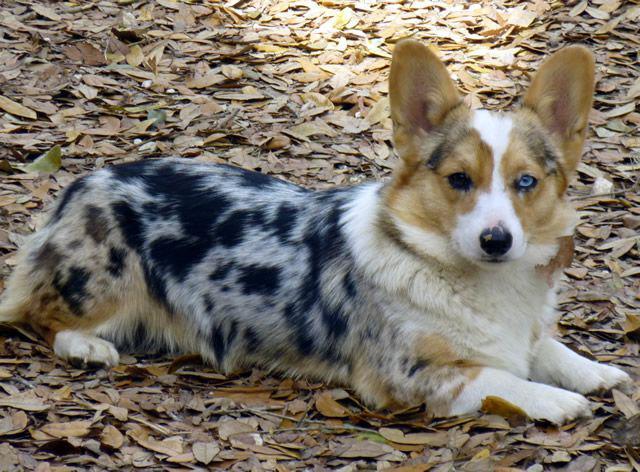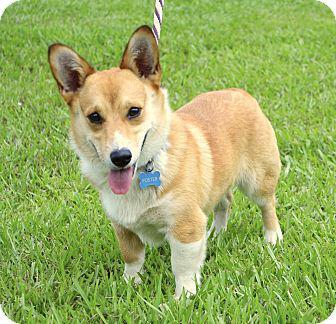The first image is the image on the left, the second image is the image on the right. Considering the images on both sides, is "The dog in the right hand image stands on grass while the dog in the left hand image does not." valid? Answer yes or no. Yes. The first image is the image on the left, the second image is the image on the right. Considering the images on both sides, is "There are two dogs and neither of them have any black fur." valid? Answer yes or no. No. The first image is the image on the left, the second image is the image on the right. Examine the images to the left and right. Is the description "An image shows one orange-and-white dog, which wears a collar with a blue doggie bone-shaped charm." accurate? Answer yes or no. Yes. 